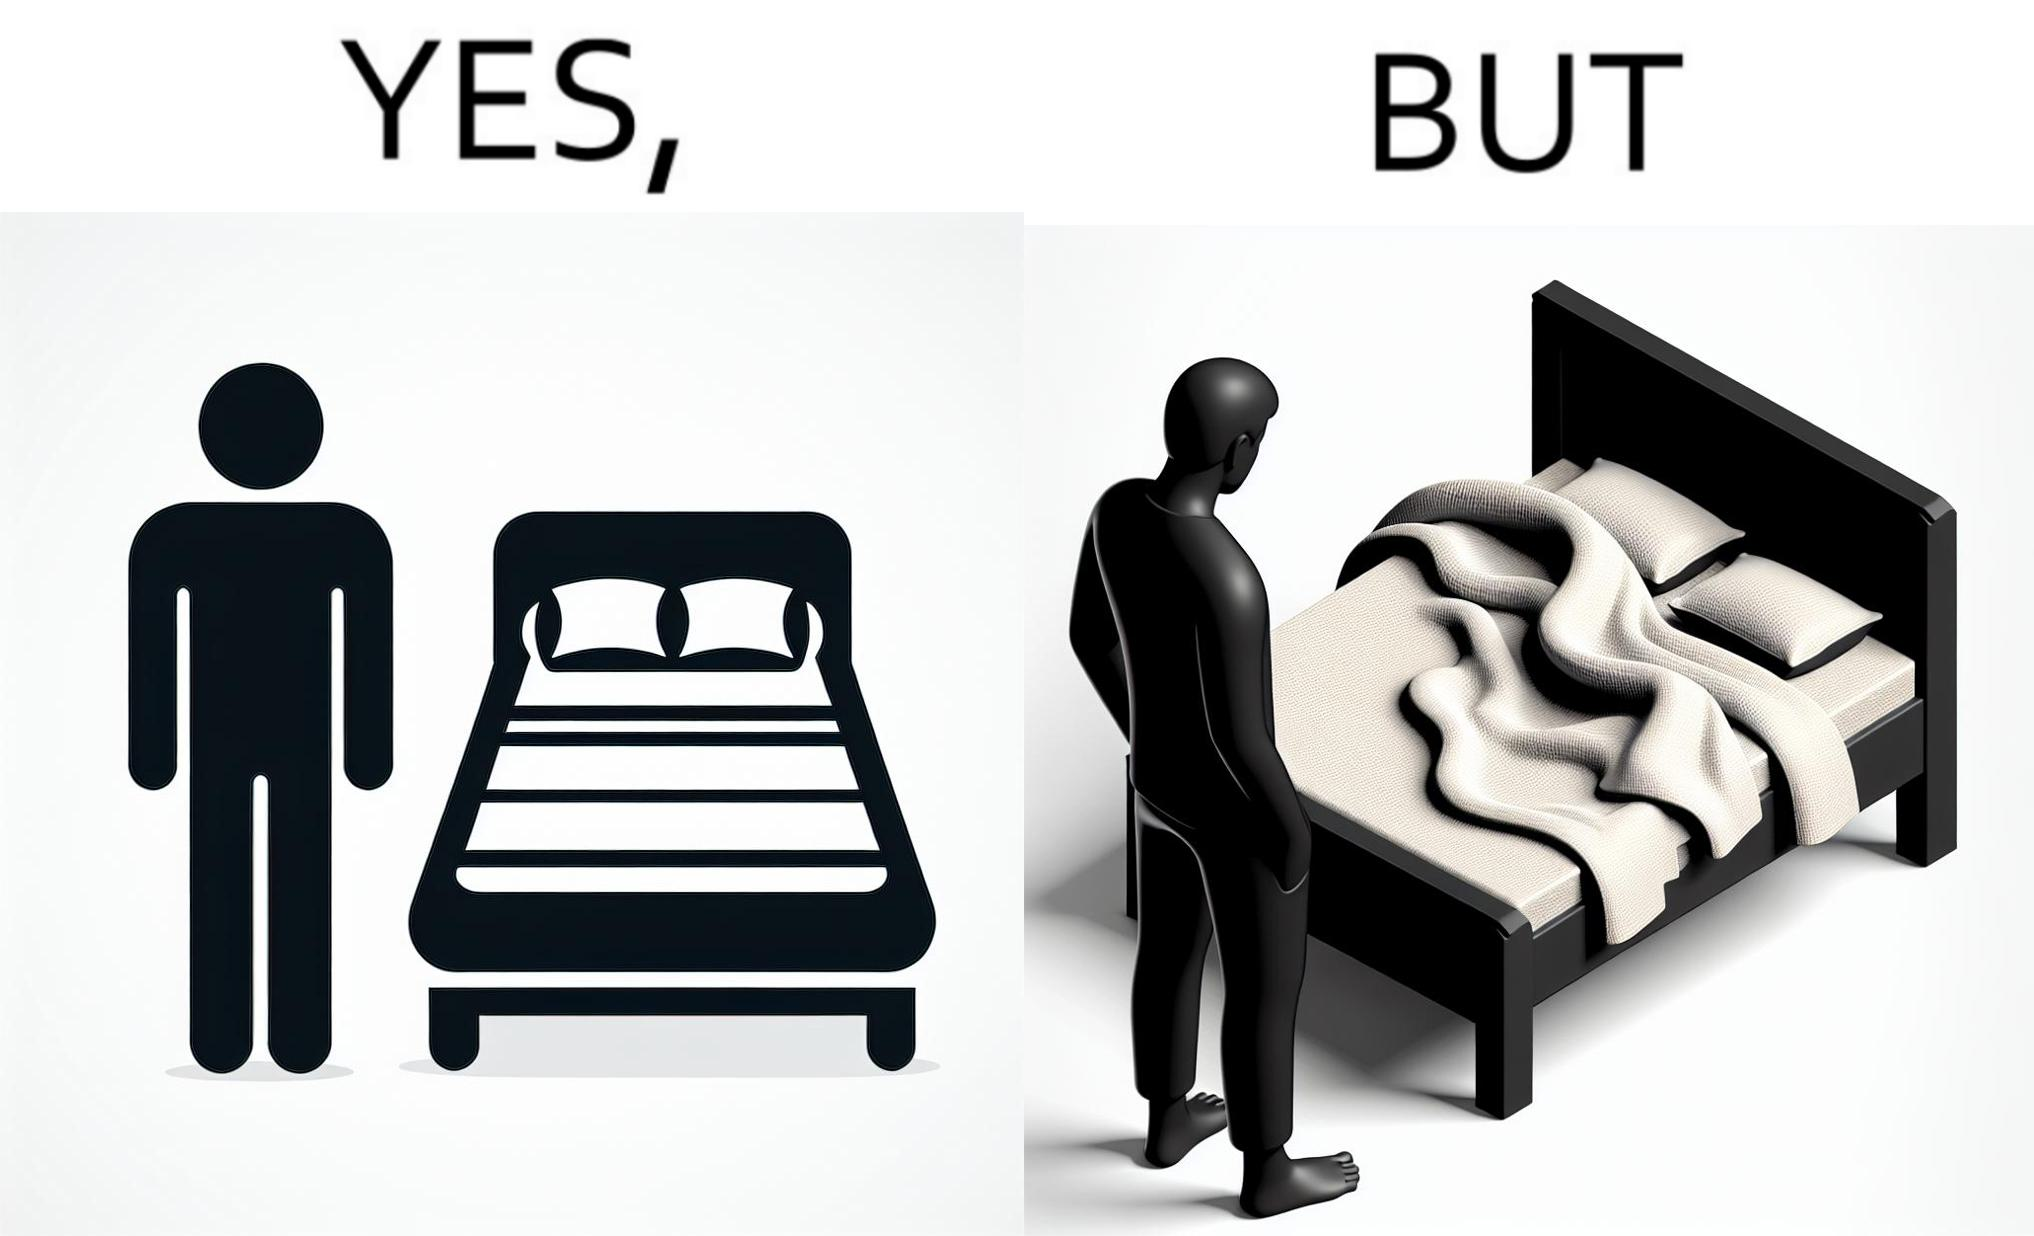Describe what you see in the left and right parts of this image. In the left part of the image: The image shows a man looking at his bed. His bed seems well made with blanket and pillow properly arranged on the mattress. In the right part of the image: The image shows a man looking at his bed. The image also shows the actual blanket inside its cover on the bed. The blanked is all twisted inside the cover and is not properly set. 